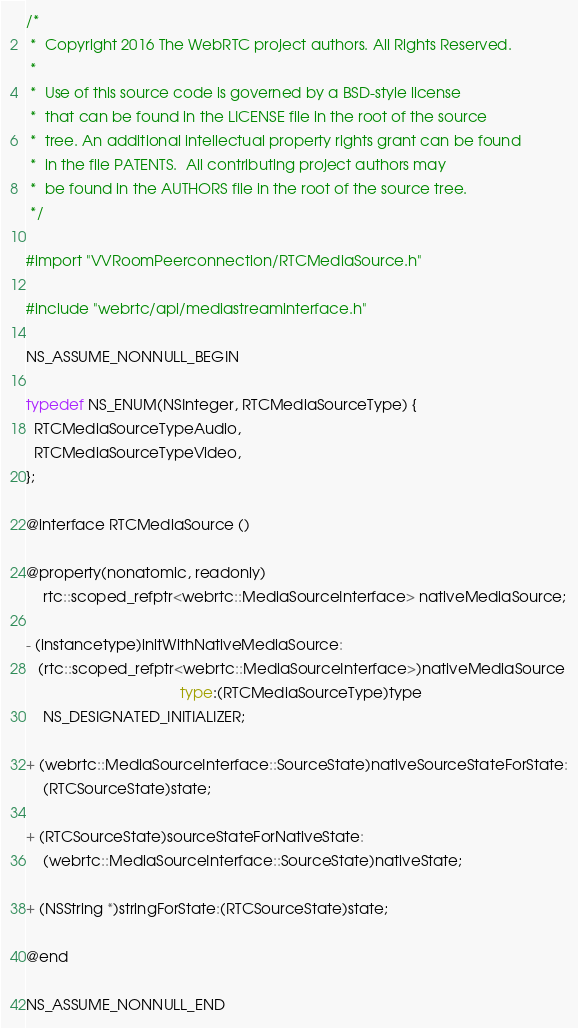<code> <loc_0><loc_0><loc_500><loc_500><_C_>/*
 *  Copyright 2016 The WebRTC project authors. All Rights Reserved.
 *
 *  Use of this source code is governed by a BSD-style license
 *  that can be found in the LICENSE file in the root of the source
 *  tree. An additional intellectual property rights grant can be found
 *  in the file PATENTS.  All contributing project authors may
 *  be found in the AUTHORS file in the root of the source tree.
 */

#import "VVRoomPeerconnection/RTCMediaSource.h"

#include "webrtc/api/mediastreaminterface.h"

NS_ASSUME_NONNULL_BEGIN

typedef NS_ENUM(NSInteger, RTCMediaSourceType) {
  RTCMediaSourceTypeAudio,
  RTCMediaSourceTypeVideo,
};

@interface RTCMediaSource ()

@property(nonatomic, readonly)
    rtc::scoped_refptr<webrtc::MediaSourceInterface> nativeMediaSource;

- (instancetype)initWithNativeMediaSource:
   (rtc::scoped_refptr<webrtc::MediaSourceInterface>)nativeMediaSource
                                     type:(RTCMediaSourceType)type
    NS_DESIGNATED_INITIALIZER;

+ (webrtc::MediaSourceInterface::SourceState)nativeSourceStateForState:
    (RTCSourceState)state;

+ (RTCSourceState)sourceStateForNativeState:
    (webrtc::MediaSourceInterface::SourceState)nativeState;

+ (NSString *)stringForState:(RTCSourceState)state;

@end

NS_ASSUME_NONNULL_END
</code> 